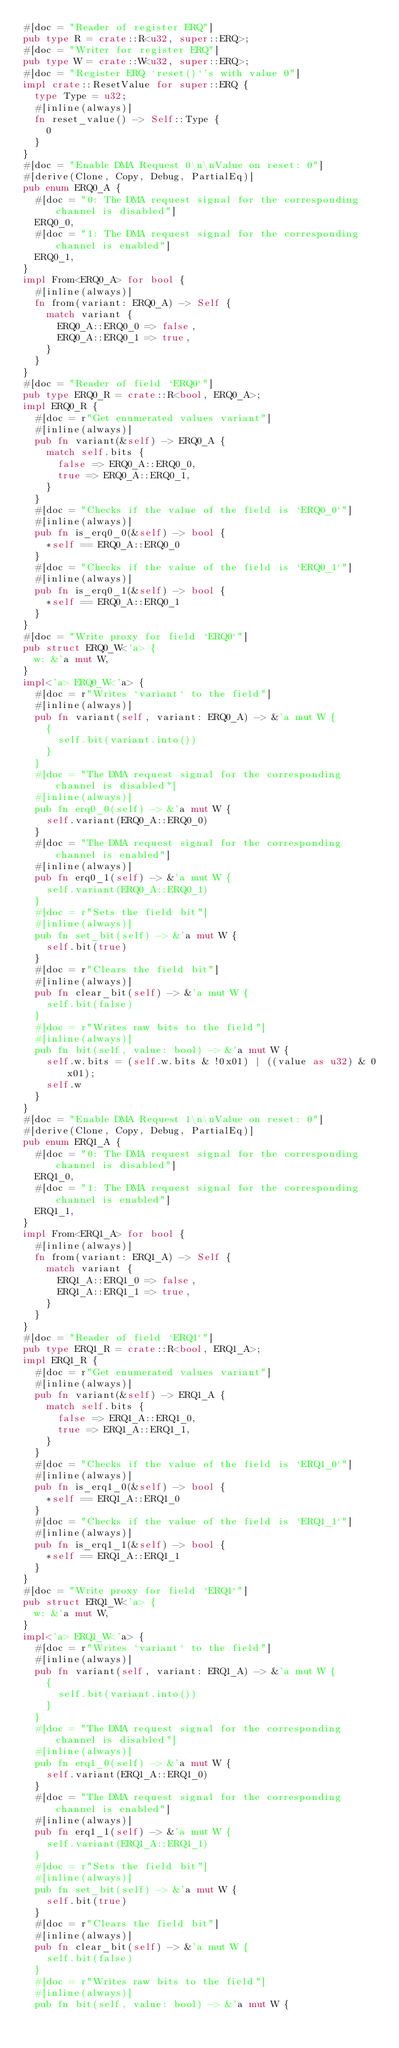<code> <loc_0><loc_0><loc_500><loc_500><_Rust_>#[doc = "Reader of register ERQ"]
pub type R = crate::R<u32, super::ERQ>;
#[doc = "Writer for register ERQ"]
pub type W = crate::W<u32, super::ERQ>;
#[doc = "Register ERQ `reset()`'s with value 0"]
impl crate::ResetValue for super::ERQ {
  type Type = u32;
  #[inline(always)]
  fn reset_value() -> Self::Type {
    0
  }
}
#[doc = "Enable DMA Request 0\n\nValue on reset: 0"]
#[derive(Clone, Copy, Debug, PartialEq)]
pub enum ERQ0_A {
  #[doc = "0: The DMA request signal for the corresponding channel is disabled"]
  ERQ0_0,
  #[doc = "1: The DMA request signal for the corresponding channel is enabled"]
  ERQ0_1,
}
impl From<ERQ0_A> for bool {
  #[inline(always)]
  fn from(variant: ERQ0_A) -> Self {
    match variant {
      ERQ0_A::ERQ0_0 => false,
      ERQ0_A::ERQ0_1 => true,
    }
  }
}
#[doc = "Reader of field `ERQ0`"]
pub type ERQ0_R = crate::R<bool, ERQ0_A>;
impl ERQ0_R {
  #[doc = r"Get enumerated values variant"]
  #[inline(always)]
  pub fn variant(&self) -> ERQ0_A {
    match self.bits {
      false => ERQ0_A::ERQ0_0,
      true => ERQ0_A::ERQ0_1,
    }
  }
  #[doc = "Checks if the value of the field is `ERQ0_0`"]
  #[inline(always)]
  pub fn is_erq0_0(&self) -> bool {
    *self == ERQ0_A::ERQ0_0
  }
  #[doc = "Checks if the value of the field is `ERQ0_1`"]
  #[inline(always)]
  pub fn is_erq0_1(&self) -> bool {
    *self == ERQ0_A::ERQ0_1
  }
}
#[doc = "Write proxy for field `ERQ0`"]
pub struct ERQ0_W<'a> {
  w: &'a mut W,
}
impl<'a> ERQ0_W<'a> {
  #[doc = r"Writes `variant` to the field"]
  #[inline(always)]
  pub fn variant(self, variant: ERQ0_A) -> &'a mut W {
    {
      self.bit(variant.into())
    }
  }
  #[doc = "The DMA request signal for the corresponding channel is disabled"]
  #[inline(always)]
  pub fn erq0_0(self) -> &'a mut W {
    self.variant(ERQ0_A::ERQ0_0)
  }
  #[doc = "The DMA request signal for the corresponding channel is enabled"]
  #[inline(always)]
  pub fn erq0_1(self) -> &'a mut W {
    self.variant(ERQ0_A::ERQ0_1)
  }
  #[doc = r"Sets the field bit"]
  #[inline(always)]
  pub fn set_bit(self) -> &'a mut W {
    self.bit(true)
  }
  #[doc = r"Clears the field bit"]
  #[inline(always)]
  pub fn clear_bit(self) -> &'a mut W {
    self.bit(false)
  }
  #[doc = r"Writes raw bits to the field"]
  #[inline(always)]
  pub fn bit(self, value: bool) -> &'a mut W {
    self.w.bits = (self.w.bits & !0x01) | ((value as u32) & 0x01);
    self.w
  }
}
#[doc = "Enable DMA Request 1\n\nValue on reset: 0"]
#[derive(Clone, Copy, Debug, PartialEq)]
pub enum ERQ1_A {
  #[doc = "0: The DMA request signal for the corresponding channel is disabled"]
  ERQ1_0,
  #[doc = "1: The DMA request signal for the corresponding channel is enabled"]
  ERQ1_1,
}
impl From<ERQ1_A> for bool {
  #[inline(always)]
  fn from(variant: ERQ1_A) -> Self {
    match variant {
      ERQ1_A::ERQ1_0 => false,
      ERQ1_A::ERQ1_1 => true,
    }
  }
}
#[doc = "Reader of field `ERQ1`"]
pub type ERQ1_R = crate::R<bool, ERQ1_A>;
impl ERQ1_R {
  #[doc = r"Get enumerated values variant"]
  #[inline(always)]
  pub fn variant(&self) -> ERQ1_A {
    match self.bits {
      false => ERQ1_A::ERQ1_0,
      true => ERQ1_A::ERQ1_1,
    }
  }
  #[doc = "Checks if the value of the field is `ERQ1_0`"]
  #[inline(always)]
  pub fn is_erq1_0(&self) -> bool {
    *self == ERQ1_A::ERQ1_0
  }
  #[doc = "Checks if the value of the field is `ERQ1_1`"]
  #[inline(always)]
  pub fn is_erq1_1(&self) -> bool {
    *self == ERQ1_A::ERQ1_1
  }
}
#[doc = "Write proxy for field `ERQ1`"]
pub struct ERQ1_W<'a> {
  w: &'a mut W,
}
impl<'a> ERQ1_W<'a> {
  #[doc = r"Writes `variant` to the field"]
  #[inline(always)]
  pub fn variant(self, variant: ERQ1_A) -> &'a mut W {
    {
      self.bit(variant.into())
    }
  }
  #[doc = "The DMA request signal for the corresponding channel is disabled"]
  #[inline(always)]
  pub fn erq1_0(self) -> &'a mut W {
    self.variant(ERQ1_A::ERQ1_0)
  }
  #[doc = "The DMA request signal for the corresponding channel is enabled"]
  #[inline(always)]
  pub fn erq1_1(self) -> &'a mut W {
    self.variant(ERQ1_A::ERQ1_1)
  }
  #[doc = r"Sets the field bit"]
  #[inline(always)]
  pub fn set_bit(self) -> &'a mut W {
    self.bit(true)
  }
  #[doc = r"Clears the field bit"]
  #[inline(always)]
  pub fn clear_bit(self) -> &'a mut W {
    self.bit(false)
  }
  #[doc = r"Writes raw bits to the field"]
  #[inline(always)]
  pub fn bit(self, value: bool) -> &'a mut W {</code> 